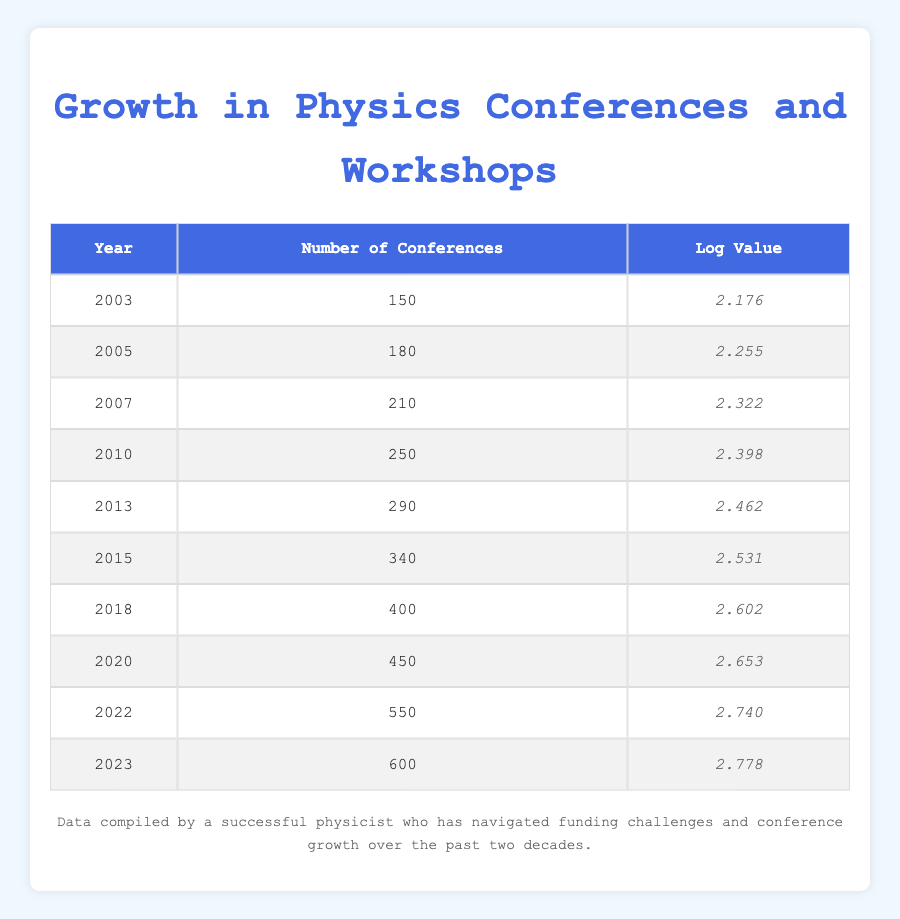What was the number of conferences held in 2010? The table indicates that in the year 2010, the number of conferences was listed directly as 250.
Answer: 250 What is the logarithmic value for the year 2022? Referring to the table, the logarithmic value corresponding to the year 2022 is 2.740.
Answer: 2.740 Which year saw the highest number of conferences held? By examining the "Number of Conferences" column, the highest value is 600, corresponding to the year 2023.
Answer: 2023 What is the difference between the number of conferences held in 2015 and 2020? The number of conferences in 2015 was 340, and in 2020 it was 450. The difference is calculated as 450 - 340 = 110.
Answer: 110 Is it true that the number of conferences in 2018 was more than 300? In the table, the number of conferences held in 2018 is listed as 400, which is greater than 300. Therefore, the statement is true.
Answer: Yes What is the average number of conferences held from 2010 to 2023? To find the average, sum the number of conferences from 2010 (250), 2013 (290), 2015 (340), 2018 (400), 2020 (450), 2022 (550), and 2023 (600). This totals to 250 + 290 + 340 + 400 + 450 + 550 + 600 = 2980. There are 7 data points, so the average is 2980 / 7 = 425.71.
Answer: 425.71 In which year did the number of conferences first exceed 300? The table shows that the number of conferences exceeded 300 in 2015, where the count rose to 340. Thus, 2015 is the first year above this threshold.
Answer: 2015 What was the combined total number of conferences from 2003 to 2010? For years 2003 through 2010, the number of conferences were: 150 (2003), 180 (2005), 210 (2007), and 250 (2010). Adding these gives: 150 + 180 + 210 + 250 = 790.
Answer: 790 How many conferences were held in 2007 and 2013 combined? Referring to the table, in 2007 there were 210 conferences and in 2013 there were 290 conferences. The sum is 210 + 290 = 500.
Answer: 500 